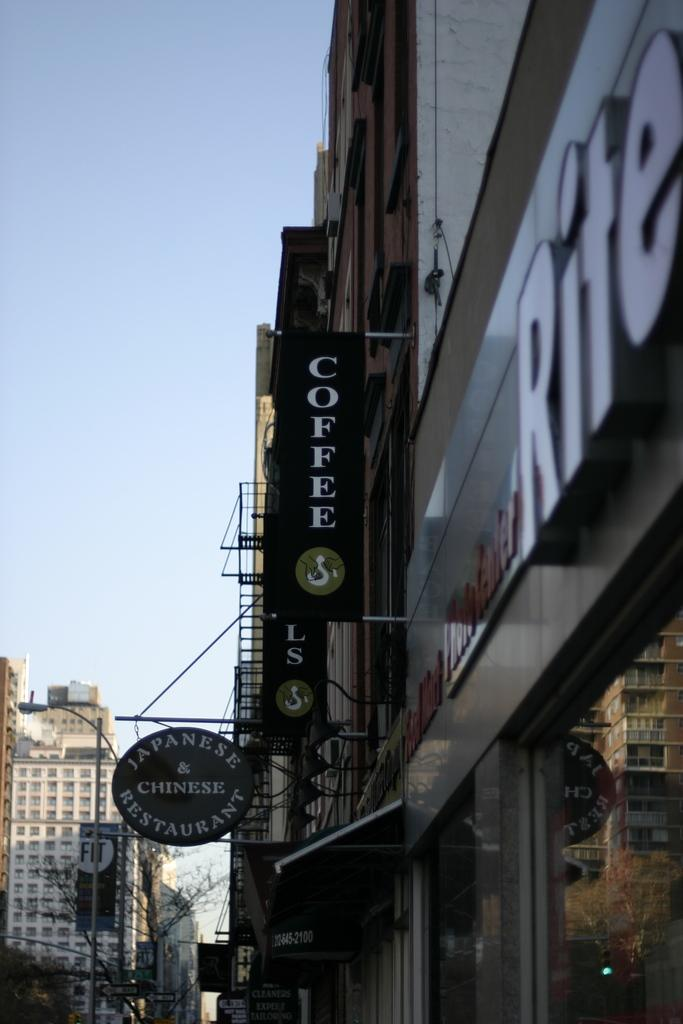What type of structures can be seen in the image? There are buildings in the image. What objects are present in the foreground of the image? There are boards and glass in the image. What can be seen through the glass in the image? Trees are visible through the glass. What is visible in the background of the image? There are buildings, light, a board on a pole, trees, and the sky in the background of the image. Can you touch the bead that is hanging from the umbrella in the image? There is no umbrella or bead present in the image. 